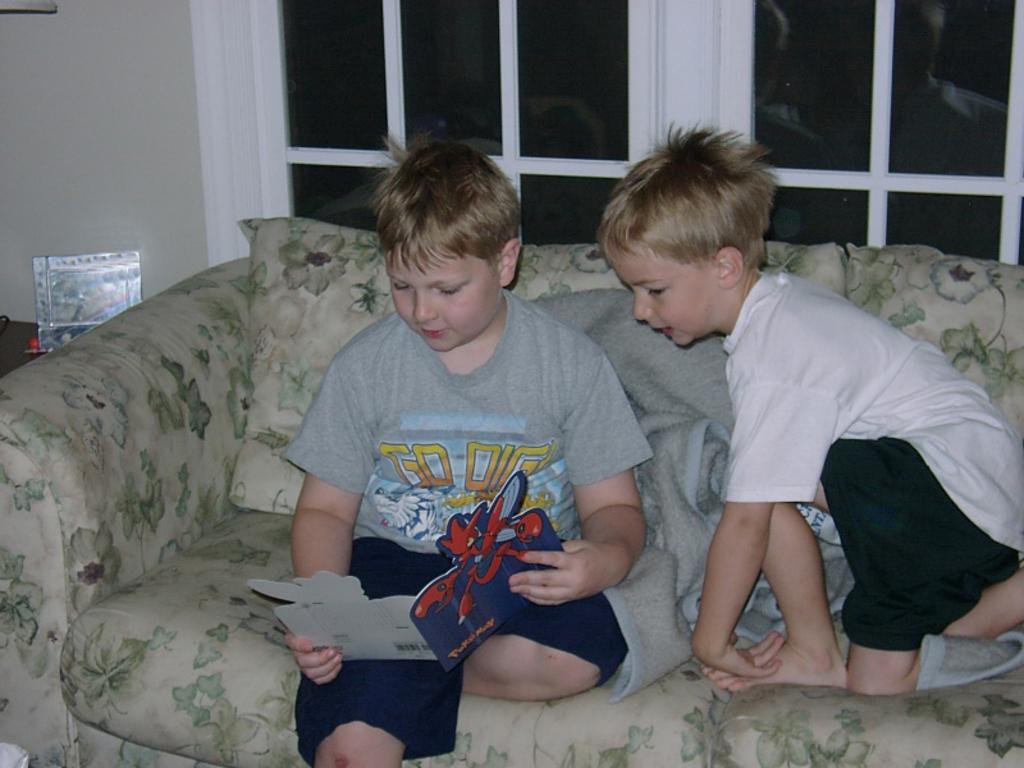Can you describe this image briefly? In this image we can see two boys are sitting on a couch. A boy is reading a book. An object is placed on the table. 